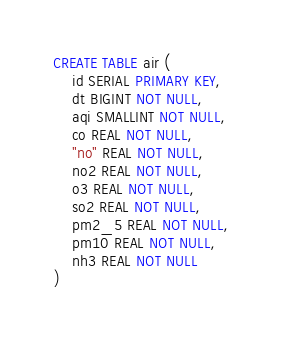<code> <loc_0><loc_0><loc_500><loc_500><_SQL_>CREATE TABLE air (
    id SERIAL PRIMARY KEY,
    dt BIGINT NOT NULL,
    aqi SMALLINT NOT NULL,
    co REAL NOT NULL,
    "no" REAL NOT NULL,
    no2 REAL NOT NULL,
    o3 REAL NOT NULL,
    so2 REAL NOT NULL,
    pm2_5 REAL NOT NULL,
    pm10 REAL NOT NULL,
    nh3 REAL NOT NULL
)</code> 